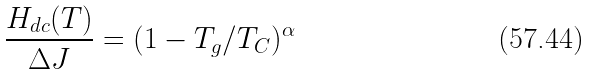Convert formula to latex. <formula><loc_0><loc_0><loc_500><loc_500>\frac { H _ { d c } ( T ) } { \Delta J } = ( 1 - T _ { g } / T _ { C } ) ^ { \alpha }</formula> 